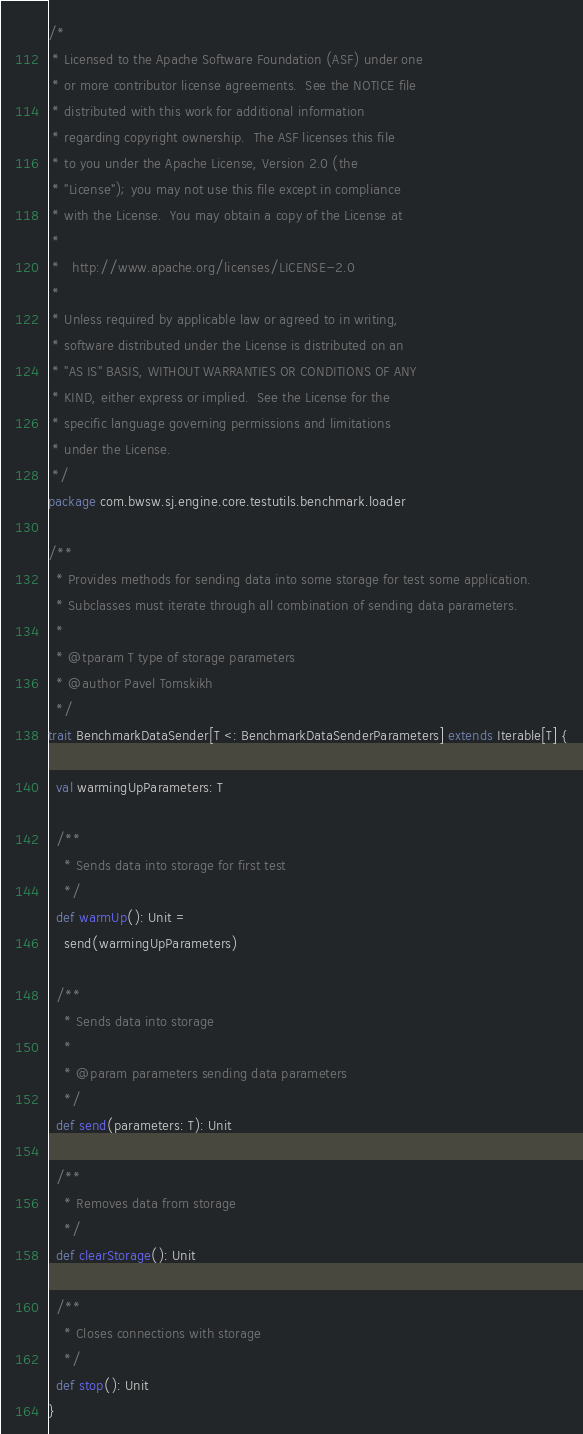Convert code to text. <code><loc_0><loc_0><loc_500><loc_500><_Scala_>/*
 * Licensed to the Apache Software Foundation (ASF) under one
 * or more contributor license agreements.  See the NOTICE file
 * distributed with this work for additional information
 * regarding copyright ownership.  The ASF licenses this file
 * to you under the Apache License, Version 2.0 (the
 * "License"); you may not use this file except in compliance
 * with the License.  You may obtain a copy of the License at
 *
 *   http://www.apache.org/licenses/LICENSE-2.0
 *
 * Unless required by applicable law or agreed to in writing,
 * software distributed under the License is distributed on an
 * "AS IS" BASIS, WITHOUT WARRANTIES OR CONDITIONS OF ANY
 * KIND, either express or implied.  See the License for the
 * specific language governing permissions and limitations
 * under the License.
 */
package com.bwsw.sj.engine.core.testutils.benchmark.loader

/**
  * Provides methods for sending data into some storage for test some application.
  * Subclasses must iterate through all combination of sending data parameters.
  *
  * @tparam T type of storage parameters
  * @author Pavel Tomskikh
  */
trait BenchmarkDataSender[T <: BenchmarkDataSenderParameters] extends Iterable[T] {

  val warmingUpParameters: T

  /**
    * Sends data into storage for first test
    */
  def warmUp(): Unit =
    send(warmingUpParameters)

  /**
    * Sends data into storage
    *
    * @param parameters sending data parameters
    */
  def send(parameters: T): Unit

  /**
    * Removes data from storage
    */
  def clearStorage(): Unit

  /**
    * Closes connections with storage
    */
  def stop(): Unit
}
</code> 